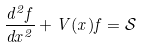Convert formula to latex. <formula><loc_0><loc_0><loc_500><loc_500>\frac { d ^ { 2 } f } { d x ^ { 2 } } + V ( x ) f = \mathcal { S }</formula> 